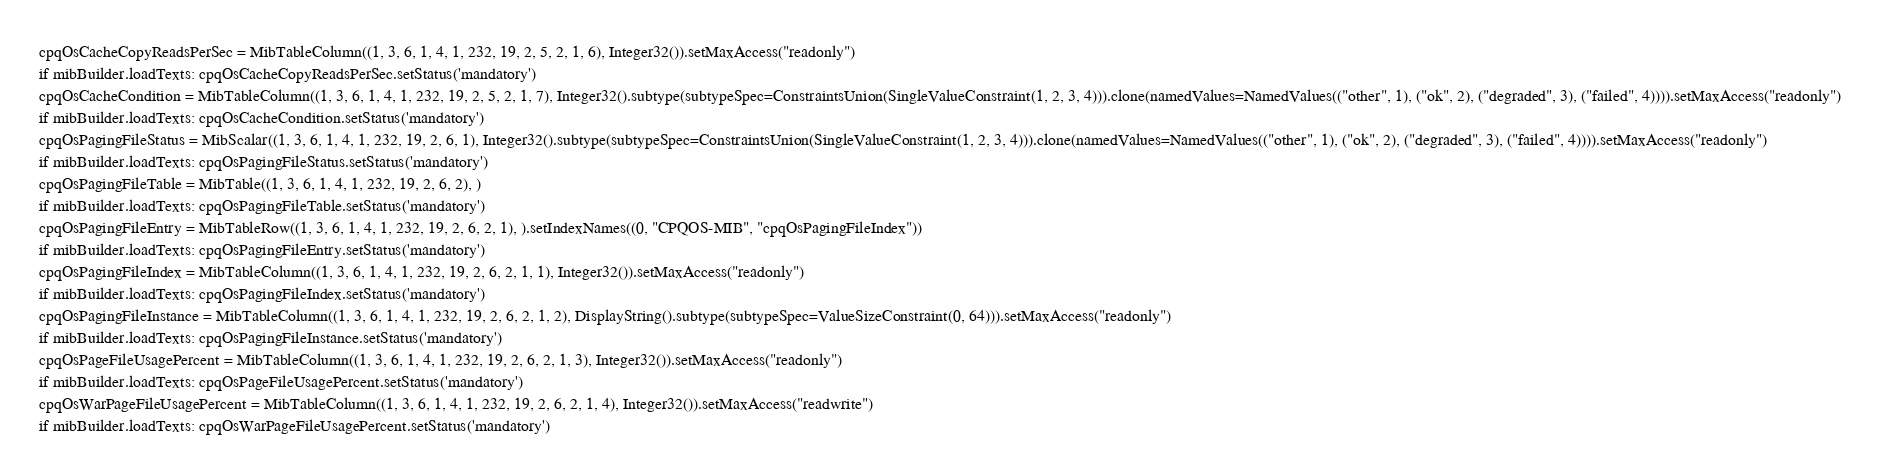Convert code to text. <code><loc_0><loc_0><loc_500><loc_500><_Python_>cpqOsCacheCopyReadsPerSec = MibTableColumn((1, 3, 6, 1, 4, 1, 232, 19, 2, 5, 2, 1, 6), Integer32()).setMaxAccess("readonly")
if mibBuilder.loadTexts: cpqOsCacheCopyReadsPerSec.setStatus('mandatory')
cpqOsCacheCondition = MibTableColumn((1, 3, 6, 1, 4, 1, 232, 19, 2, 5, 2, 1, 7), Integer32().subtype(subtypeSpec=ConstraintsUnion(SingleValueConstraint(1, 2, 3, 4))).clone(namedValues=NamedValues(("other", 1), ("ok", 2), ("degraded", 3), ("failed", 4)))).setMaxAccess("readonly")
if mibBuilder.loadTexts: cpqOsCacheCondition.setStatus('mandatory')
cpqOsPagingFileStatus = MibScalar((1, 3, 6, 1, 4, 1, 232, 19, 2, 6, 1), Integer32().subtype(subtypeSpec=ConstraintsUnion(SingleValueConstraint(1, 2, 3, 4))).clone(namedValues=NamedValues(("other", 1), ("ok", 2), ("degraded", 3), ("failed", 4)))).setMaxAccess("readonly")
if mibBuilder.loadTexts: cpqOsPagingFileStatus.setStatus('mandatory')
cpqOsPagingFileTable = MibTable((1, 3, 6, 1, 4, 1, 232, 19, 2, 6, 2), )
if mibBuilder.loadTexts: cpqOsPagingFileTable.setStatus('mandatory')
cpqOsPagingFileEntry = MibTableRow((1, 3, 6, 1, 4, 1, 232, 19, 2, 6, 2, 1), ).setIndexNames((0, "CPQOS-MIB", "cpqOsPagingFileIndex"))
if mibBuilder.loadTexts: cpqOsPagingFileEntry.setStatus('mandatory')
cpqOsPagingFileIndex = MibTableColumn((1, 3, 6, 1, 4, 1, 232, 19, 2, 6, 2, 1, 1), Integer32()).setMaxAccess("readonly")
if mibBuilder.loadTexts: cpqOsPagingFileIndex.setStatus('mandatory')
cpqOsPagingFileInstance = MibTableColumn((1, 3, 6, 1, 4, 1, 232, 19, 2, 6, 2, 1, 2), DisplayString().subtype(subtypeSpec=ValueSizeConstraint(0, 64))).setMaxAccess("readonly")
if mibBuilder.loadTexts: cpqOsPagingFileInstance.setStatus('mandatory')
cpqOsPageFileUsagePercent = MibTableColumn((1, 3, 6, 1, 4, 1, 232, 19, 2, 6, 2, 1, 3), Integer32()).setMaxAccess("readonly")
if mibBuilder.loadTexts: cpqOsPageFileUsagePercent.setStatus('mandatory')
cpqOsWarPageFileUsagePercent = MibTableColumn((1, 3, 6, 1, 4, 1, 232, 19, 2, 6, 2, 1, 4), Integer32()).setMaxAccess("readwrite")
if mibBuilder.loadTexts: cpqOsWarPageFileUsagePercent.setStatus('mandatory')</code> 